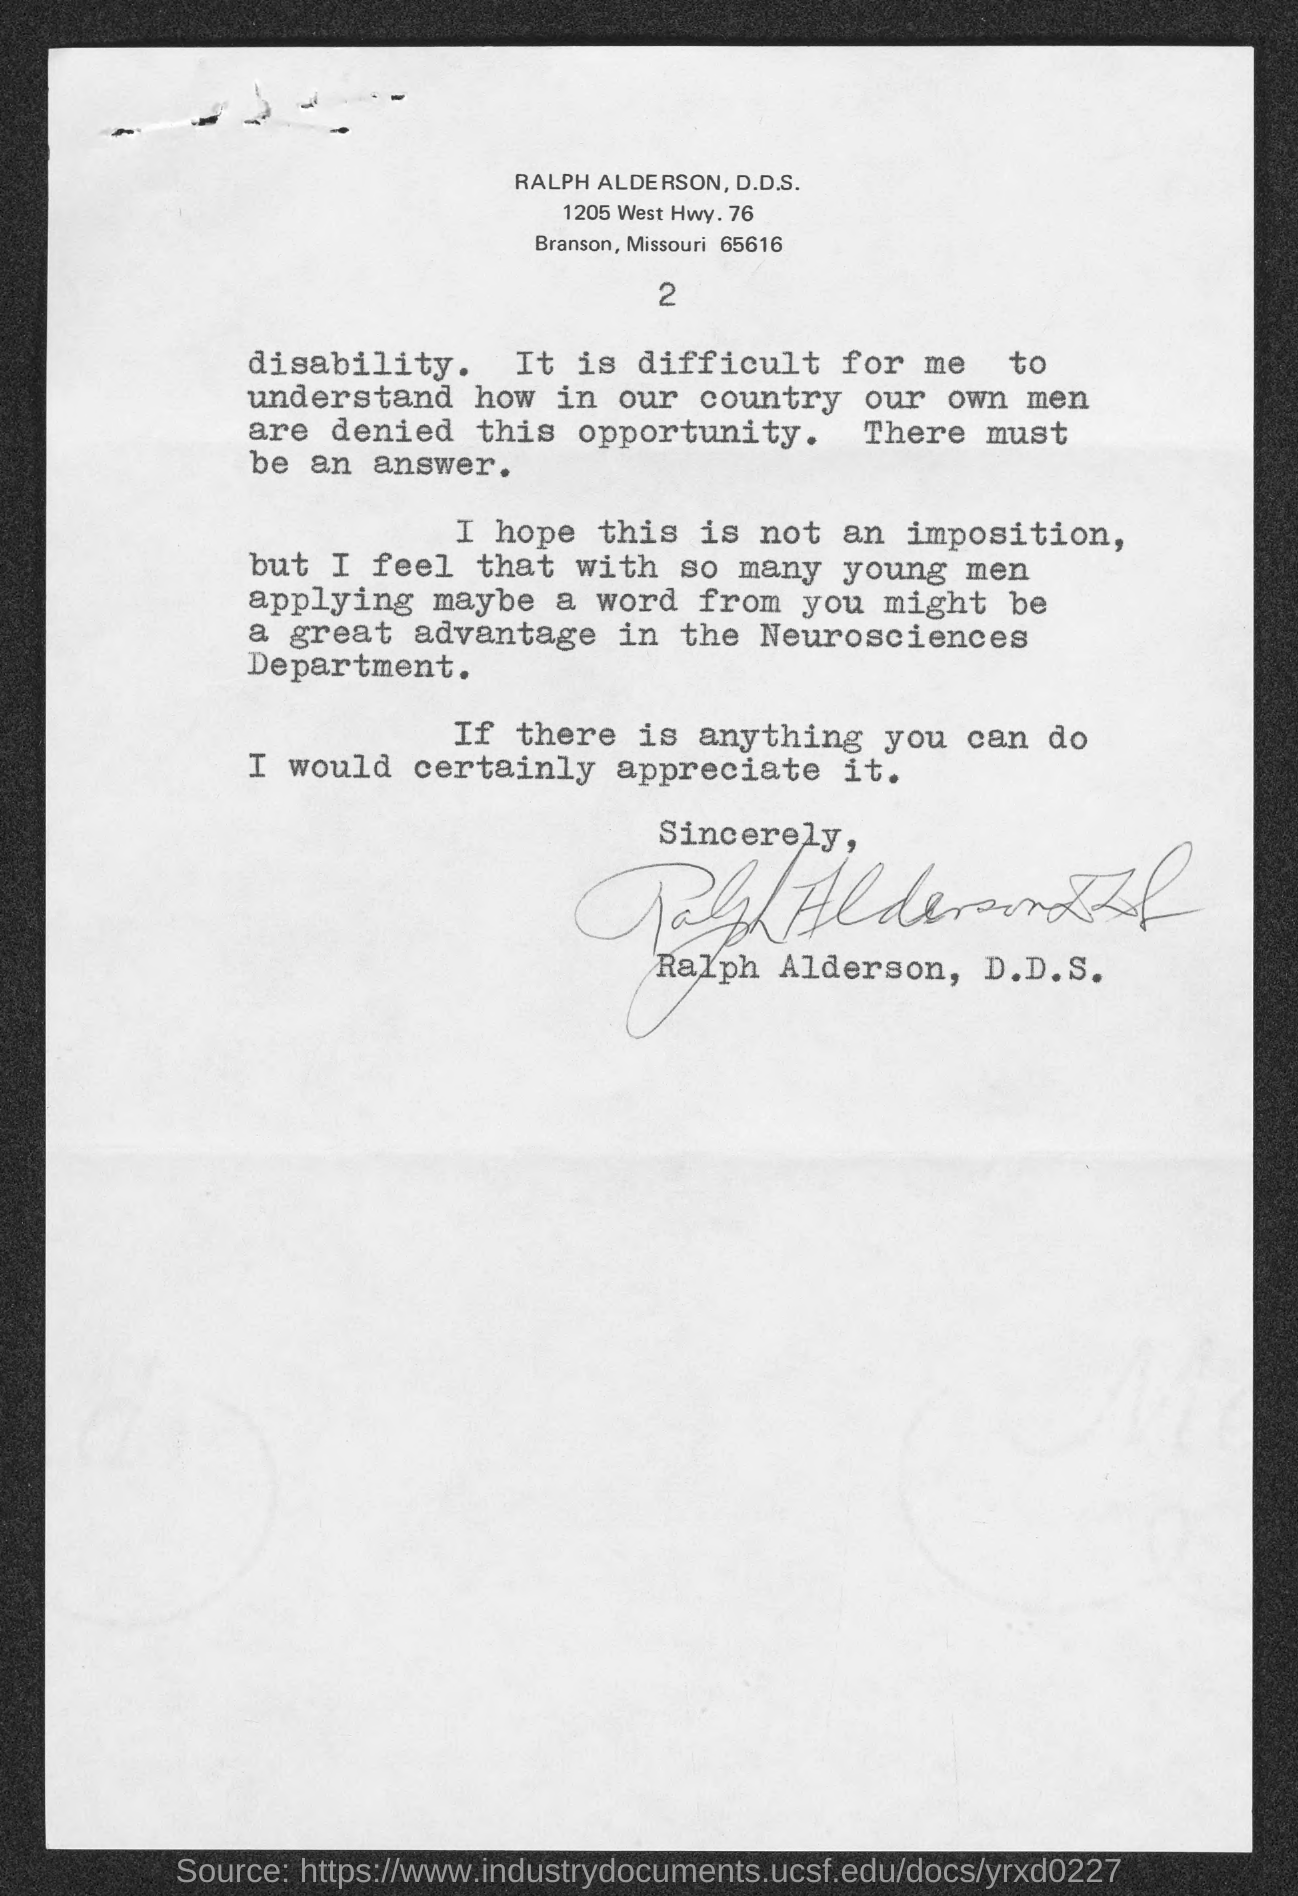Outline some significant characteristics in this image. The page number is 2, as indicated by the range 2.. 